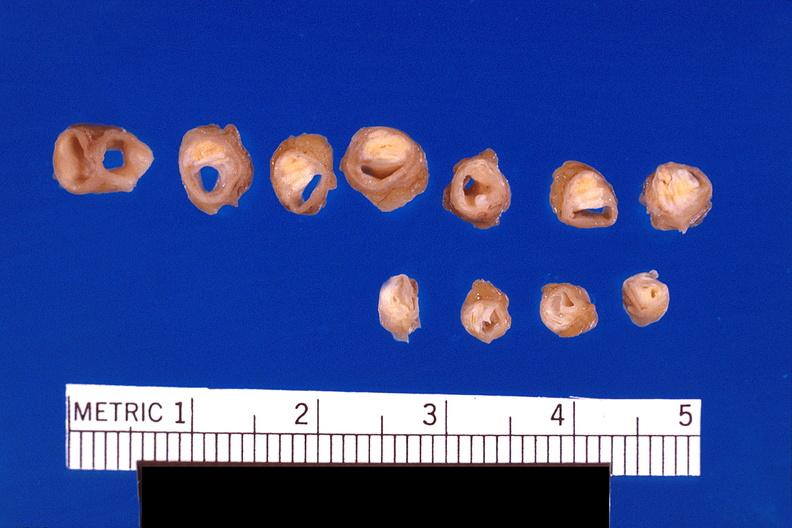how is atherosclerosis left anterior descending artery?
Answer the question using a single word or phrase. Coronary 